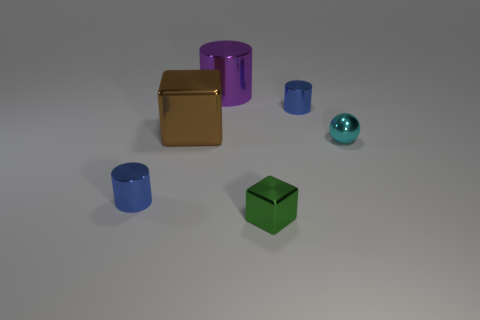Subtract all blue cylinders. How many cylinders are left? 1 Subtract all purple cylinders. How many cylinders are left? 2 Add 1 big brown blocks. How many objects exist? 7 Subtract 2 cubes. How many cubes are left? 0 Subtract all purple balls. How many brown cubes are left? 1 Subtract all cylinders. Subtract all blocks. How many objects are left? 1 Add 3 metallic cylinders. How many metallic cylinders are left? 6 Add 2 big cylinders. How many big cylinders exist? 3 Subtract 0 cyan blocks. How many objects are left? 6 Subtract all spheres. How many objects are left? 5 